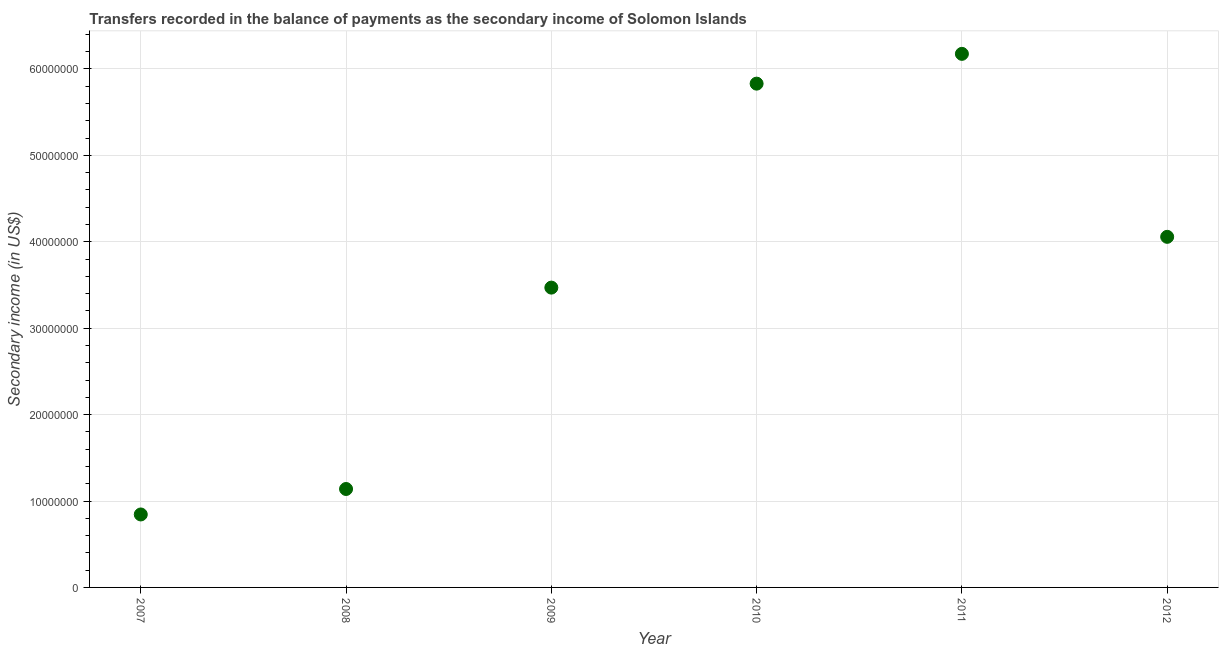What is the amount of secondary income in 2007?
Make the answer very short. 8.44e+06. Across all years, what is the maximum amount of secondary income?
Ensure brevity in your answer.  6.17e+07. Across all years, what is the minimum amount of secondary income?
Your response must be concise. 8.44e+06. In which year was the amount of secondary income maximum?
Your answer should be compact. 2011. In which year was the amount of secondary income minimum?
Provide a short and direct response. 2007. What is the sum of the amount of secondary income?
Keep it short and to the point. 2.15e+08. What is the difference between the amount of secondary income in 2010 and 2012?
Provide a succinct answer. 1.77e+07. What is the average amount of secondary income per year?
Your answer should be compact. 3.59e+07. What is the median amount of secondary income?
Provide a short and direct response. 3.76e+07. In how many years, is the amount of secondary income greater than 18000000 US$?
Offer a terse response. 4. What is the ratio of the amount of secondary income in 2008 to that in 2009?
Your response must be concise. 0.33. Is the difference between the amount of secondary income in 2007 and 2012 greater than the difference between any two years?
Your answer should be very brief. No. What is the difference between the highest and the second highest amount of secondary income?
Your response must be concise. 3.45e+06. What is the difference between the highest and the lowest amount of secondary income?
Offer a terse response. 5.33e+07. Does the amount of secondary income monotonically increase over the years?
Give a very brief answer. No. How many dotlines are there?
Offer a very short reply. 1. How many years are there in the graph?
Make the answer very short. 6. Are the values on the major ticks of Y-axis written in scientific E-notation?
Your answer should be very brief. No. Does the graph contain any zero values?
Give a very brief answer. No. What is the title of the graph?
Keep it short and to the point. Transfers recorded in the balance of payments as the secondary income of Solomon Islands. What is the label or title of the X-axis?
Provide a short and direct response. Year. What is the label or title of the Y-axis?
Offer a very short reply. Secondary income (in US$). What is the Secondary income (in US$) in 2007?
Provide a succinct answer. 8.44e+06. What is the Secondary income (in US$) in 2008?
Make the answer very short. 1.14e+07. What is the Secondary income (in US$) in 2009?
Offer a very short reply. 3.47e+07. What is the Secondary income (in US$) in 2010?
Ensure brevity in your answer.  5.83e+07. What is the Secondary income (in US$) in 2011?
Offer a terse response. 6.17e+07. What is the Secondary income (in US$) in 2012?
Give a very brief answer. 4.06e+07. What is the difference between the Secondary income (in US$) in 2007 and 2008?
Your answer should be very brief. -2.95e+06. What is the difference between the Secondary income (in US$) in 2007 and 2009?
Provide a short and direct response. -2.62e+07. What is the difference between the Secondary income (in US$) in 2007 and 2010?
Ensure brevity in your answer.  -4.99e+07. What is the difference between the Secondary income (in US$) in 2007 and 2011?
Make the answer very short. -5.33e+07. What is the difference between the Secondary income (in US$) in 2007 and 2012?
Your answer should be very brief. -3.21e+07. What is the difference between the Secondary income (in US$) in 2008 and 2009?
Offer a terse response. -2.33e+07. What is the difference between the Secondary income (in US$) in 2008 and 2010?
Your answer should be very brief. -4.69e+07. What is the difference between the Secondary income (in US$) in 2008 and 2011?
Offer a very short reply. -5.04e+07. What is the difference between the Secondary income (in US$) in 2008 and 2012?
Provide a short and direct response. -2.92e+07. What is the difference between the Secondary income (in US$) in 2009 and 2010?
Offer a terse response. -2.36e+07. What is the difference between the Secondary income (in US$) in 2009 and 2011?
Make the answer very short. -2.70e+07. What is the difference between the Secondary income (in US$) in 2009 and 2012?
Your answer should be very brief. -5.88e+06. What is the difference between the Secondary income (in US$) in 2010 and 2011?
Your answer should be compact. -3.45e+06. What is the difference between the Secondary income (in US$) in 2010 and 2012?
Provide a succinct answer. 1.77e+07. What is the difference between the Secondary income (in US$) in 2011 and 2012?
Give a very brief answer. 2.12e+07. What is the ratio of the Secondary income (in US$) in 2007 to that in 2008?
Your answer should be very brief. 0.74. What is the ratio of the Secondary income (in US$) in 2007 to that in 2009?
Offer a terse response. 0.24. What is the ratio of the Secondary income (in US$) in 2007 to that in 2010?
Give a very brief answer. 0.14. What is the ratio of the Secondary income (in US$) in 2007 to that in 2011?
Your response must be concise. 0.14. What is the ratio of the Secondary income (in US$) in 2007 to that in 2012?
Your answer should be compact. 0.21. What is the ratio of the Secondary income (in US$) in 2008 to that in 2009?
Your response must be concise. 0.33. What is the ratio of the Secondary income (in US$) in 2008 to that in 2010?
Your answer should be compact. 0.2. What is the ratio of the Secondary income (in US$) in 2008 to that in 2011?
Your answer should be compact. 0.18. What is the ratio of the Secondary income (in US$) in 2008 to that in 2012?
Provide a short and direct response. 0.28. What is the ratio of the Secondary income (in US$) in 2009 to that in 2010?
Your answer should be compact. 0.59. What is the ratio of the Secondary income (in US$) in 2009 to that in 2011?
Make the answer very short. 0.56. What is the ratio of the Secondary income (in US$) in 2009 to that in 2012?
Keep it short and to the point. 0.85. What is the ratio of the Secondary income (in US$) in 2010 to that in 2011?
Give a very brief answer. 0.94. What is the ratio of the Secondary income (in US$) in 2010 to that in 2012?
Offer a terse response. 1.44. What is the ratio of the Secondary income (in US$) in 2011 to that in 2012?
Make the answer very short. 1.52. 